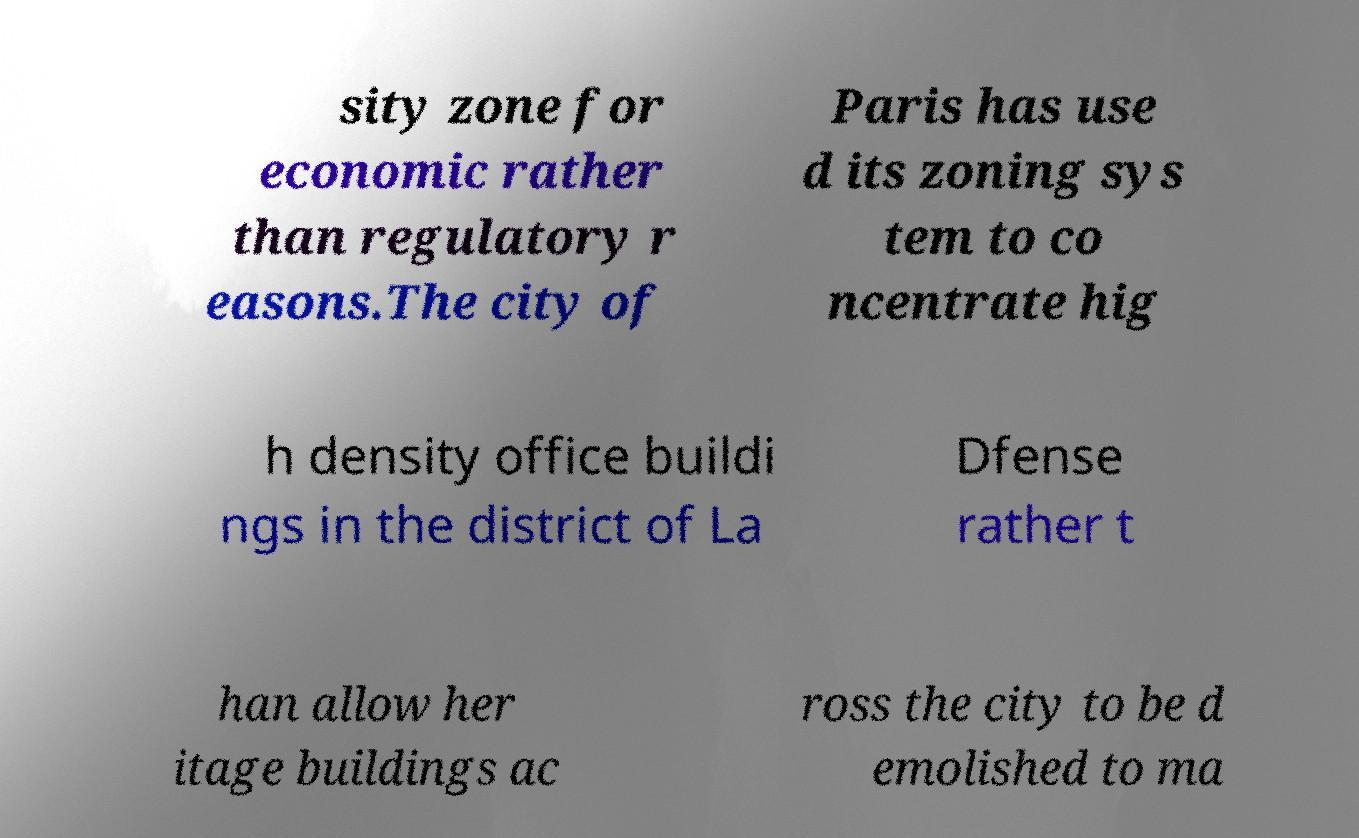Can you read and provide the text displayed in the image?This photo seems to have some interesting text. Can you extract and type it out for me? sity zone for economic rather than regulatory r easons.The city of Paris has use d its zoning sys tem to co ncentrate hig h density office buildi ngs in the district of La Dfense rather t han allow her itage buildings ac ross the city to be d emolished to ma 